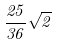<formula> <loc_0><loc_0><loc_500><loc_500>\frac { 2 5 } { 3 6 } \sqrt { 2 }</formula> 